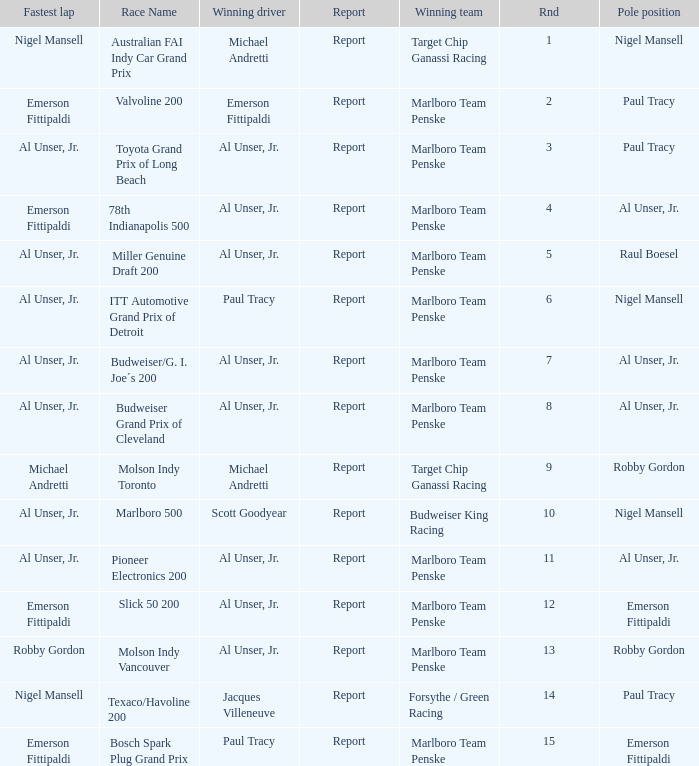Who was on the pole position in the Texaco/Havoline 200 race? Paul Tracy. 